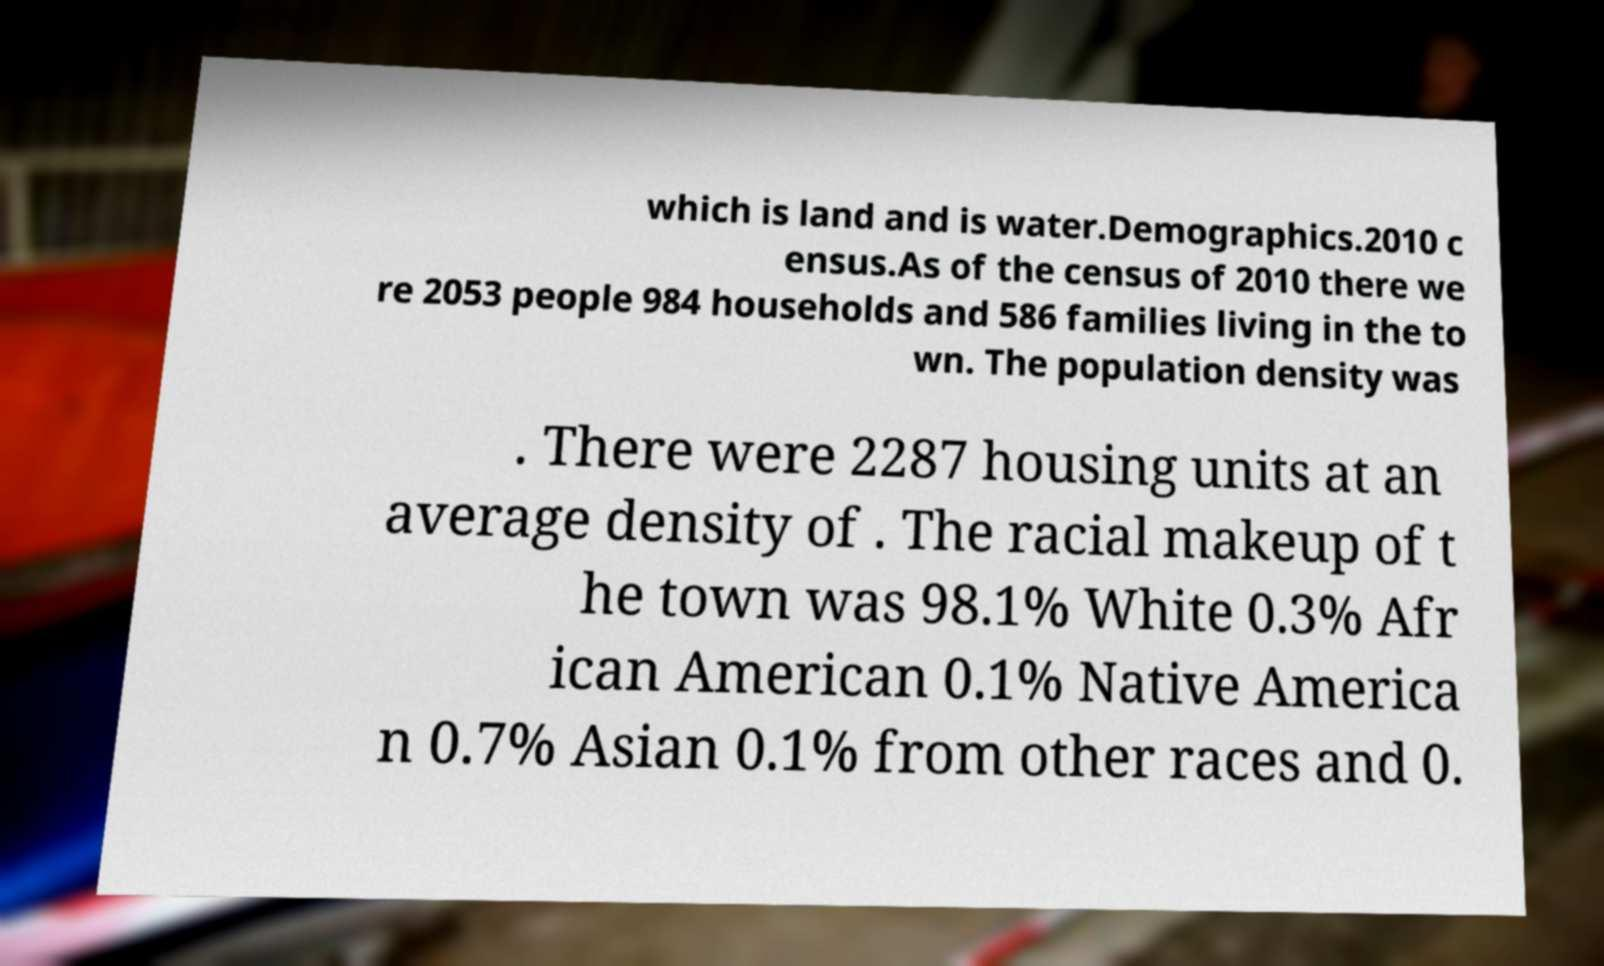Could you extract and type out the text from this image? which is land and is water.Demographics.2010 c ensus.As of the census of 2010 there we re 2053 people 984 households and 586 families living in the to wn. The population density was . There were 2287 housing units at an average density of . The racial makeup of t he town was 98.1% White 0.3% Afr ican American 0.1% Native America n 0.7% Asian 0.1% from other races and 0. 